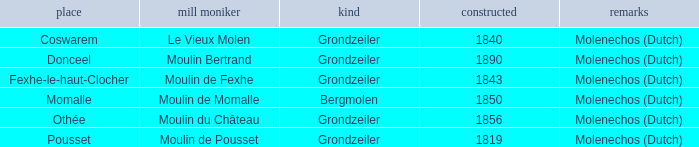What is the Name of the Grondzeiler Mill? Le Vieux Molen, Moulin Bertrand, Moulin de Fexhe, Moulin du Château, Moulin de Pousset. 